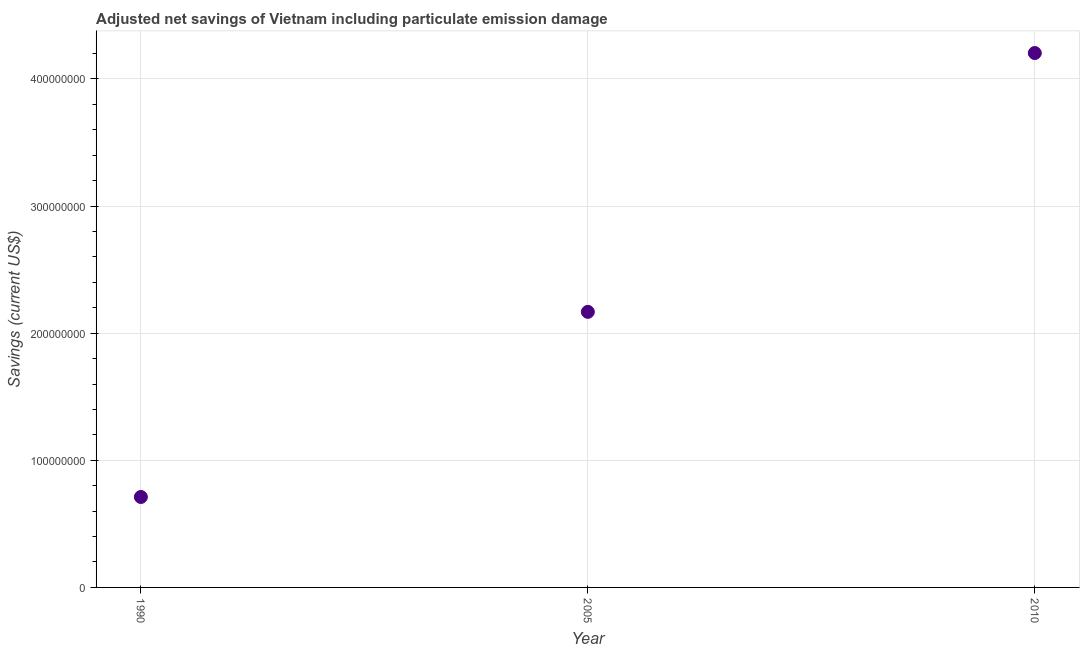What is the adjusted net savings in 1990?
Ensure brevity in your answer.  7.11e+07. Across all years, what is the maximum adjusted net savings?
Your response must be concise. 4.20e+08. Across all years, what is the minimum adjusted net savings?
Make the answer very short. 7.11e+07. What is the sum of the adjusted net savings?
Provide a short and direct response. 7.08e+08. What is the difference between the adjusted net savings in 2005 and 2010?
Your answer should be compact. -2.04e+08. What is the average adjusted net savings per year?
Offer a terse response. 2.36e+08. What is the median adjusted net savings?
Give a very brief answer. 2.17e+08. In how many years, is the adjusted net savings greater than 20000000 US$?
Offer a very short reply. 3. What is the ratio of the adjusted net savings in 1990 to that in 2010?
Your answer should be compact. 0.17. Is the adjusted net savings in 1990 less than that in 2010?
Your response must be concise. Yes. What is the difference between the highest and the second highest adjusted net savings?
Give a very brief answer. 2.04e+08. Is the sum of the adjusted net savings in 2005 and 2010 greater than the maximum adjusted net savings across all years?
Ensure brevity in your answer.  Yes. What is the difference between the highest and the lowest adjusted net savings?
Your response must be concise. 3.49e+08. In how many years, is the adjusted net savings greater than the average adjusted net savings taken over all years?
Make the answer very short. 1. What is the difference between two consecutive major ticks on the Y-axis?
Ensure brevity in your answer.  1.00e+08. Does the graph contain any zero values?
Give a very brief answer. No. Does the graph contain grids?
Offer a very short reply. Yes. What is the title of the graph?
Offer a very short reply. Adjusted net savings of Vietnam including particulate emission damage. What is the label or title of the X-axis?
Keep it short and to the point. Year. What is the label or title of the Y-axis?
Keep it short and to the point. Savings (current US$). What is the Savings (current US$) in 1990?
Your answer should be very brief. 7.11e+07. What is the Savings (current US$) in 2005?
Keep it short and to the point. 2.17e+08. What is the Savings (current US$) in 2010?
Make the answer very short. 4.20e+08. What is the difference between the Savings (current US$) in 1990 and 2005?
Your response must be concise. -1.46e+08. What is the difference between the Savings (current US$) in 1990 and 2010?
Your answer should be very brief. -3.49e+08. What is the difference between the Savings (current US$) in 2005 and 2010?
Offer a very short reply. -2.04e+08. What is the ratio of the Savings (current US$) in 1990 to that in 2005?
Your answer should be compact. 0.33. What is the ratio of the Savings (current US$) in 1990 to that in 2010?
Your answer should be compact. 0.17. What is the ratio of the Savings (current US$) in 2005 to that in 2010?
Offer a very short reply. 0.52. 